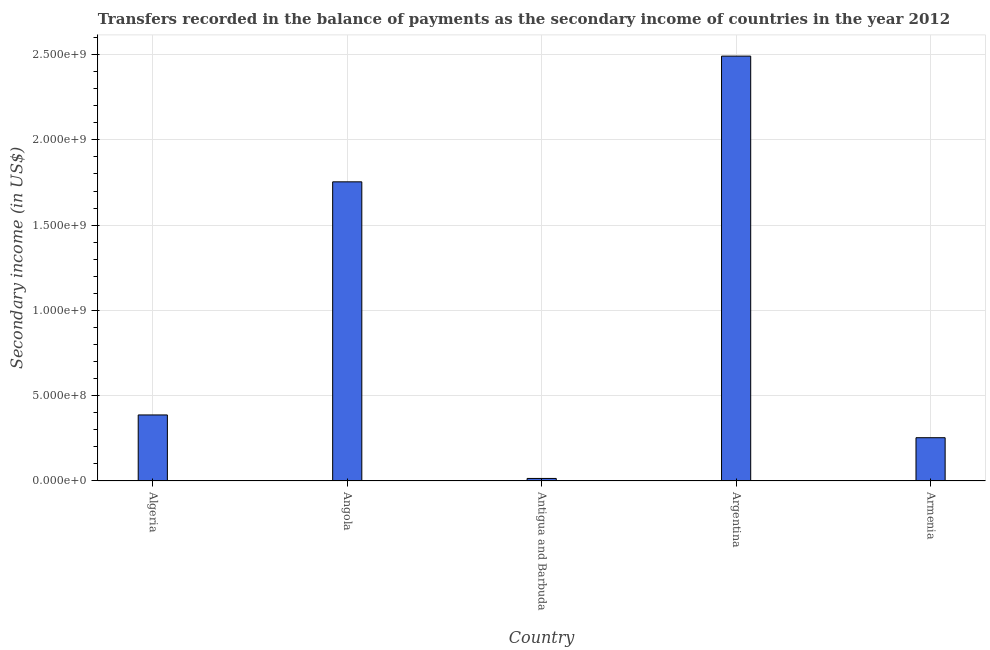Does the graph contain any zero values?
Your answer should be compact. No. What is the title of the graph?
Keep it short and to the point. Transfers recorded in the balance of payments as the secondary income of countries in the year 2012. What is the label or title of the X-axis?
Offer a terse response. Country. What is the label or title of the Y-axis?
Provide a short and direct response. Secondary income (in US$). What is the amount of secondary income in Algeria?
Give a very brief answer. 3.87e+08. Across all countries, what is the maximum amount of secondary income?
Your answer should be very brief. 2.49e+09. Across all countries, what is the minimum amount of secondary income?
Ensure brevity in your answer.  1.49e+07. In which country was the amount of secondary income maximum?
Keep it short and to the point. Argentina. In which country was the amount of secondary income minimum?
Your response must be concise. Antigua and Barbuda. What is the sum of the amount of secondary income?
Make the answer very short. 4.90e+09. What is the difference between the amount of secondary income in Algeria and Antigua and Barbuda?
Offer a very short reply. 3.72e+08. What is the average amount of secondary income per country?
Your answer should be compact. 9.80e+08. What is the median amount of secondary income?
Keep it short and to the point. 3.87e+08. In how many countries, is the amount of secondary income greater than 1900000000 US$?
Your answer should be very brief. 1. What is the ratio of the amount of secondary income in Angola to that in Antigua and Barbuda?
Offer a very short reply. 117.59. Is the amount of secondary income in Algeria less than that in Argentina?
Offer a very short reply. Yes. What is the difference between the highest and the second highest amount of secondary income?
Provide a succinct answer. 7.37e+08. Is the sum of the amount of secondary income in Antigua and Barbuda and Argentina greater than the maximum amount of secondary income across all countries?
Offer a terse response. Yes. What is the difference between the highest and the lowest amount of secondary income?
Offer a very short reply. 2.48e+09. In how many countries, is the amount of secondary income greater than the average amount of secondary income taken over all countries?
Provide a succinct answer. 2. How many bars are there?
Offer a terse response. 5. Are all the bars in the graph horizontal?
Keep it short and to the point. No. How many countries are there in the graph?
Your response must be concise. 5. What is the difference between two consecutive major ticks on the Y-axis?
Give a very brief answer. 5.00e+08. What is the Secondary income (in US$) of Algeria?
Offer a terse response. 3.87e+08. What is the Secondary income (in US$) of Angola?
Your response must be concise. 1.75e+09. What is the Secondary income (in US$) in Antigua and Barbuda?
Make the answer very short. 1.49e+07. What is the Secondary income (in US$) in Argentina?
Ensure brevity in your answer.  2.49e+09. What is the Secondary income (in US$) in Armenia?
Your answer should be very brief. 2.54e+08. What is the difference between the Secondary income (in US$) in Algeria and Angola?
Offer a terse response. -1.37e+09. What is the difference between the Secondary income (in US$) in Algeria and Antigua and Barbuda?
Offer a very short reply. 3.72e+08. What is the difference between the Secondary income (in US$) in Algeria and Argentina?
Offer a very short reply. -2.10e+09. What is the difference between the Secondary income (in US$) in Algeria and Armenia?
Ensure brevity in your answer.  1.33e+08. What is the difference between the Secondary income (in US$) in Angola and Antigua and Barbuda?
Give a very brief answer. 1.74e+09. What is the difference between the Secondary income (in US$) in Angola and Argentina?
Your response must be concise. -7.37e+08. What is the difference between the Secondary income (in US$) in Angola and Armenia?
Offer a very short reply. 1.50e+09. What is the difference between the Secondary income (in US$) in Antigua and Barbuda and Argentina?
Give a very brief answer. -2.48e+09. What is the difference between the Secondary income (in US$) in Antigua and Barbuda and Armenia?
Provide a succinct answer. -2.39e+08. What is the difference between the Secondary income (in US$) in Argentina and Armenia?
Your response must be concise. 2.24e+09. What is the ratio of the Secondary income (in US$) in Algeria to that in Angola?
Make the answer very short. 0.22. What is the ratio of the Secondary income (in US$) in Algeria to that in Antigua and Barbuda?
Provide a succinct answer. 25.96. What is the ratio of the Secondary income (in US$) in Algeria to that in Argentina?
Offer a terse response. 0.15. What is the ratio of the Secondary income (in US$) in Algeria to that in Armenia?
Provide a short and direct response. 1.53. What is the ratio of the Secondary income (in US$) in Angola to that in Antigua and Barbuda?
Offer a very short reply. 117.59. What is the ratio of the Secondary income (in US$) in Angola to that in Argentina?
Ensure brevity in your answer.  0.7. What is the ratio of the Secondary income (in US$) in Angola to that in Armenia?
Your answer should be very brief. 6.91. What is the ratio of the Secondary income (in US$) in Antigua and Barbuda to that in Argentina?
Provide a succinct answer. 0.01. What is the ratio of the Secondary income (in US$) in Antigua and Barbuda to that in Armenia?
Provide a short and direct response. 0.06. What is the ratio of the Secondary income (in US$) in Argentina to that in Armenia?
Your answer should be compact. 9.82. 